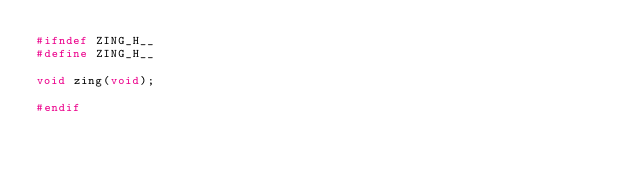<code> <loc_0><loc_0><loc_500><loc_500><_C_>#ifndef ZING_H__
#define ZING_H__

void zing(void);

#endif
</code> 